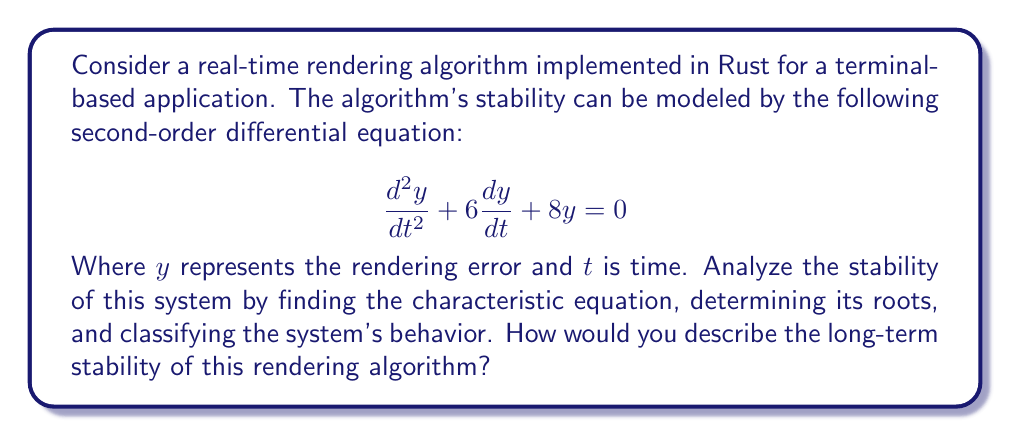Give your solution to this math problem. To analyze the stability of this real-time rendering algorithm, we'll follow these steps:

1) First, we need to find the characteristic equation of the given second-order differential equation. The general form of a second-order linear differential equation is:

   $$a\frac{d^2y}{dt^2} + b\frac{dy}{dt} + cy = 0$$

   The characteristic equation is then given by:

   $$ar^2 + br + c = 0$$

   In our case, $a=1$, $b=6$, and $c=8$. So our characteristic equation is:

   $$r^2 + 6r + 8 = 0$$

2) Now, we need to solve this quadratic equation. We can use the quadratic formula:

   $$r = \frac{-b \pm \sqrt{b^2 - 4ac}}{2a}$$

   Substituting our values:

   $$r = \frac{-6 \pm \sqrt{6^2 - 4(1)(8)}}{2(1)} = \frac{-6 \pm \sqrt{36 - 32}}{2} = \frac{-6 \pm \sqrt{4}}{2} = \frac{-6 \pm 2}{2}$$

3) This gives us two roots:

   $$r_1 = \frac{-6 + 2}{2} = -2$$
   $$r_2 = \frac{-6 - 2}{2} = -4$$

4) The general solution to our differential equation is:

   $$y(t) = C_1e^{r_1t} + C_2e^{r_2t} = C_1e^{-2t} + C_2e^{-4t}$$

   Where $C_1$ and $C_2$ are constants determined by initial conditions.

5) To classify the system's behavior, we look at the nature of these roots:
   - Both roots are real and negative.
   - The roots are distinct (not equal to each other).

   This indicates that the system is overdamped.

6) In terms of stability, both exponential terms in the solution will decay to zero as $t$ approaches infinity, because both exponents are negative. This means the rendering error $y$ will approach zero over time, regardless of the initial conditions.

Therefore, this rendering algorithm is asymptotically stable. Any initial errors or perturbations will be corrected over time, leading to a stable rendering output in the long term.
Answer: The real-time rendering algorithm is asymptotically stable. The characteristic equation $r^2 + 6r + 8 = 0$ has two distinct negative real roots: $r_1 = -2$ and $r_2 = -4$. This indicates an overdamped system where any rendering errors will decay exponentially to zero over time, ensuring long-term stability of the rendering output. 